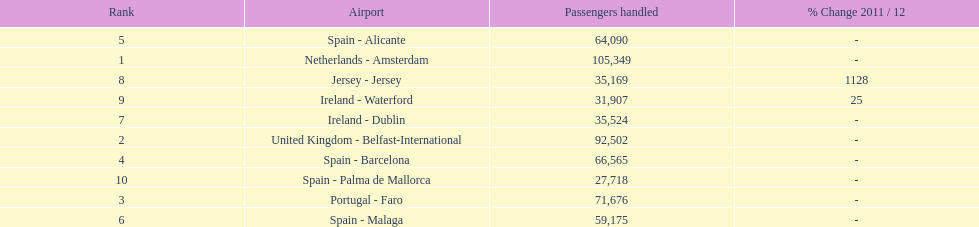How many airports are listed? 10. 